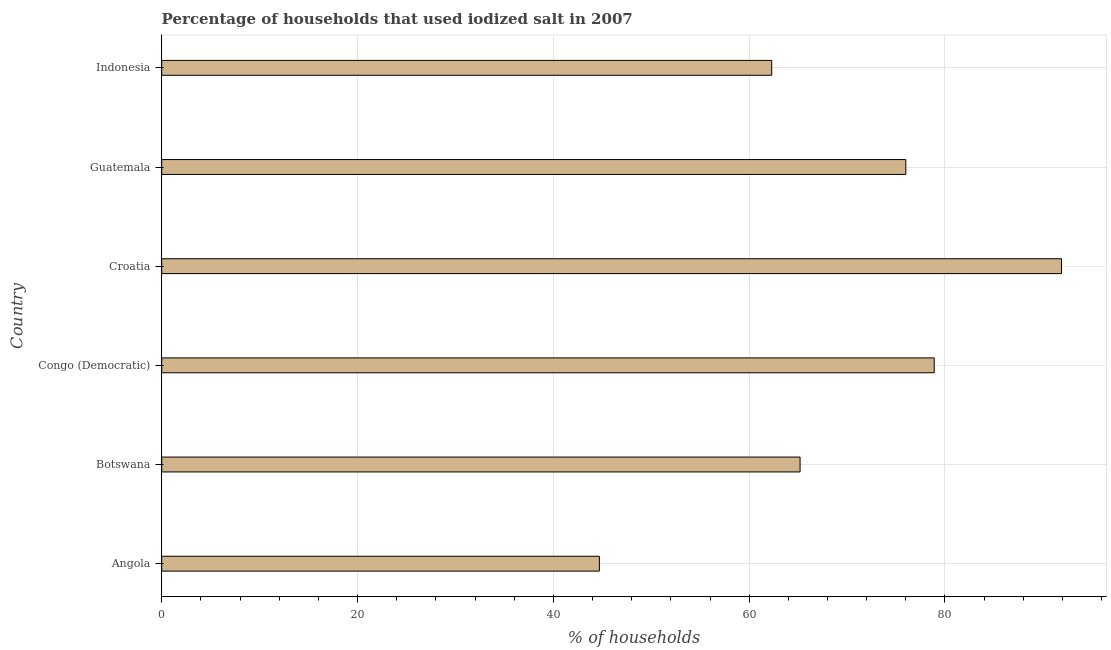Does the graph contain any zero values?
Provide a succinct answer. No. What is the title of the graph?
Provide a succinct answer. Percentage of households that used iodized salt in 2007. What is the label or title of the X-axis?
Ensure brevity in your answer.  % of households. What is the label or title of the Y-axis?
Offer a very short reply. Country. What is the percentage of households where iodized salt is consumed in Congo (Democratic)?
Offer a terse response. 78.9. Across all countries, what is the maximum percentage of households where iodized salt is consumed?
Provide a short and direct response. 91.9. Across all countries, what is the minimum percentage of households where iodized salt is consumed?
Offer a very short reply. 44.7. In which country was the percentage of households where iodized salt is consumed maximum?
Your answer should be compact. Croatia. In which country was the percentage of households where iodized salt is consumed minimum?
Your answer should be very brief. Angola. What is the sum of the percentage of households where iodized salt is consumed?
Make the answer very short. 419. What is the difference between the percentage of households where iodized salt is consumed in Congo (Democratic) and Guatemala?
Ensure brevity in your answer.  2.9. What is the average percentage of households where iodized salt is consumed per country?
Provide a short and direct response. 69.83. What is the median percentage of households where iodized salt is consumed?
Your response must be concise. 70.6. What is the ratio of the percentage of households where iodized salt is consumed in Croatia to that in Guatemala?
Offer a terse response. 1.21. Is the difference between the percentage of households where iodized salt is consumed in Congo (Democratic) and Croatia greater than the difference between any two countries?
Make the answer very short. No. Is the sum of the percentage of households where iodized salt is consumed in Angola and Croatia greater than the maximum percentage of households where iodized salt is consumed across all countries?
Your response must be concise. Yes. What is the difference between the highest and the lowest percentage of households where iodized salt is consumed?
Ensure brevity in your answer.  47.2. In how many countries, is the percentage of households where iodized salt is consumed greater than the average percentage of households where iodized salt is consumed taken over all countries?
Keep it short and to the point. 3. How many bars are there?
Provide a succinct answer. 6. How many countries are there in the graph?
Your response must be concise. 6. What is the difference between two consecutive major ticks on the X-axis?
Your response must be concise. 20. Are the values on the major ticks of X-axis written in scientific E-notation?
Your answer should be compact. No. What is the % of households in Angola?
Keep it short and to the point. 44.7. What is the % of households of Botswana?
Ensure brevity in your answer.  65.2. What is the % of households of Congo (Democratic)?
Provide a short and direct response. 78.9. What is the % of households in Croatia?
Give a very brief answer. 91.9. What is the % of households in Guatemala?
Offer a very short reply. 76. What is the % of households of Indonesia?
Provide a short and direct response. 62.3. What is the difference between the % of households in Angola and Botswana?
Ensure brevity in your answer.  -20.5. What is the difference between the % of households in Angola and Congo (Democratic)?
Provide a succinct answer. -34.2. What is the difference between the % of households in Angola and Croatia?
Ensure brevity in your answer.  -47.2. What is the difference between the % of households in Angola and Guatemala?
Make the answer very short. -31.3. What is the difference between the % of households in Angola and Indonesia?
Provide a short and direct response. -17.6. What is the difference between the % of households in Botswana and Congo (Democratic)?
Your answer should be compact. -13.7. What is the difference between the % of households in Botswana and Croatia?
Your answer should be compact. -26.7. What is the difference between the % of households in Croatia and Indonesia?
Give a very brief answer. 29.6. What is the ratio of the % of households in Angola to that in Botswana?
Your response must be concise. 0.69. What is the ratio of the % of households in Angola to that in Congo (Democratic)?
Give a very brief answer. 0.57. What is the ratio of the % of households in Angola to that in Croatia?
Give a very brief answer. 0.49. What is the ratio of the % of households in Angola to that in Guatemala?
Your answer should be very brief. 0.59. What is the ratio of the % of households in Angola to that in Indonesia?
Provide a succinct answer. 0.72. What is the ratio of the % of households in Botswana to that in Congo (Democratic)?
Make the answer very short. 0.83. What is the ratio of the % of households in Botswana to that in Croatia?
Ensure brevity in your answer.  0.71. What is the ratio of the % of households in Botswana to that in Guatemala?
Provide a succinct answer. 0.86. What is the ratio of the % of households in Botswana to that in Indonesia?
Offer a very short reply. 1.05. What is the ratio of the % of households in Congo (Democratic) to that in Croatia?
Provide a succinct answer. 0.86. What is the ratio of the % of households in Congo (Democratic) to that in Guatemala?
Keep it short and to the point. 1.04. What is the ratio of the % of households in Congo (Democratic) to that in Indonesia?
Your response must be concise. 1.27. What is the ratio of the % of households in Croatia to that in Guatemala?
Keep it short and to the point. 1.21. What is the ratio of the % of households in Croatia to that in Indonesia?
Keep it short and to the point. 1.48. What is the ratio of the % of households in Guatemala to that in Indonesia?
Your answer should be very brief. 1.22. 